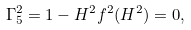<formula> <loc_0><loc_0><loc_500><loc_500>\Gamma ^ { 2 } _ { 5 } = 1 - H ^ { 2 } f ^ { 2 } ( H ^ { 2 } ) = 0 ,</formula> 